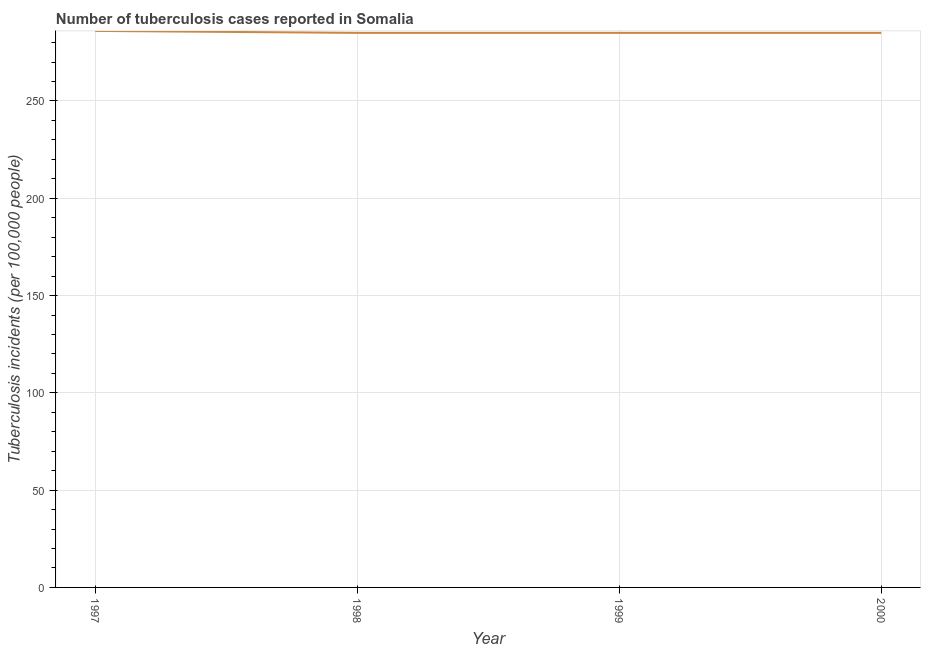What is the number of tuberculosis incidents in 1998?
Offer a terse response. 285. Across all years, what is the maximum number of tuberculosis incidents?
Provide a succinct answer. 286. Across all years, what is the minimum number of tuberculosis incidents?
Offer a very short reply. 285. In which year was the number of tuberculosis incidents maximum?
Give a very brief answer. 1997. In which year was the number of tuberculosis incidents minimum?
Offer a terse response. 1998. What is the sum of the number of tuberculosis incidents?
Your answer should be compact. 1141. What is the difference between the number of tuberculosis incidents in 1997 and 1998?
Keep it short and to the point. 1. What is the average number of tuberculosis incidents per year?
Provide a succinct answer. 285.25. What is the median number of tuberculosis incidents?
Offer a very short reply. 285. Do a majority of the years between 1999 and 2000 (inclusive) have number of tuberculosis incidents greater than 70 ?
Your answer should be compact. Yes. What is the ratio of the number of tuberculosis incidents in 1997 to that in 1999?
Provide a short and direct response. 1. Is the number of tuberculosis incidents in 1998 less than that in 2000?
Ensure brevity in your answer.  No. What is the difference between the highest and the second highest number of tuberculosis incidents?
Make the answer very short. 1. Is the sum of the number of tuberculosis incidents in 1997 and 1998 greater than the maximum number of tuberculosis incidents across all years?
Provide a succinct answer. Yes. What is the difference between the highest and the lowest number of tuberculosis incidents?
Provide a succinct answer. 1. In how many years, is the number of tuberculosis incidents greater than the average number of tuberculosis incidents taken over all years?
Provide a succinct answer. 1. Does the number of tuberculosis incidents monotonically increase over the years?
Your answer should be very brief. No. What is the difference between two consecutive major ticks on the Y-axis?
Your response must be concise. 50. Are the values on the major ticks of Y-axis written in scientific E-notation?
Make the answer very short. No. Does the graph contain any zero values?
Offer a very short reply. No. Does the graph contain grids?
Make the answer very short. Yes. What is the title of the graph?
Ensure brevity in your answer.  Number of tuberculosis cases reported in Somalia. What is the label or title of the X-axis?
Provide a succinct answer. Year. What is the label or title of the Y-axis?
Keep it short and to the point. Tuberculosis incidents (per 100,0 people). What is the Tuberculosis incidents (per 100,000 people) in 1997?
Offer a terse response. 286. What is the Tuberculosis incidents (per 100,000 people) in 1998?
Offer a terse response. 285. What is the Tuberculosis incidents (per 100,000 people) in 1999?
Your answer should be very brief. 285. What is the Tuberculosis incidents (per 100,000 people) of 2000?
Ensure brevity in your answer.  285. What is the difference between the Tuberculosis incidents (per 100,000 people) in 1997 and 1998?
Make the answer very short. 1. What is the difference between the Tuberculosis incidents (per 100,000 people) in 1998 and 2000?
Make the answer very short. 0. What is the difference between the Tuberculosis incidents (per 100,000 people) in 1999 and 2000?
Make the answer very short. 0. What is the ratio of the Tuberculosis incidents (per 100,000 people) in 1998 to that in 1999?
Give a very brief answer. 1. What is the ratio of the Tuberculosis incidents (per 100,000 people) in 1998 to that in 2000?
Provide a short and direct response. 1. What is the ratio of the Tuberculosis incidents (per 100,000 people) in 1999 to that in 2000?
Provide a succinct answer. 1. 